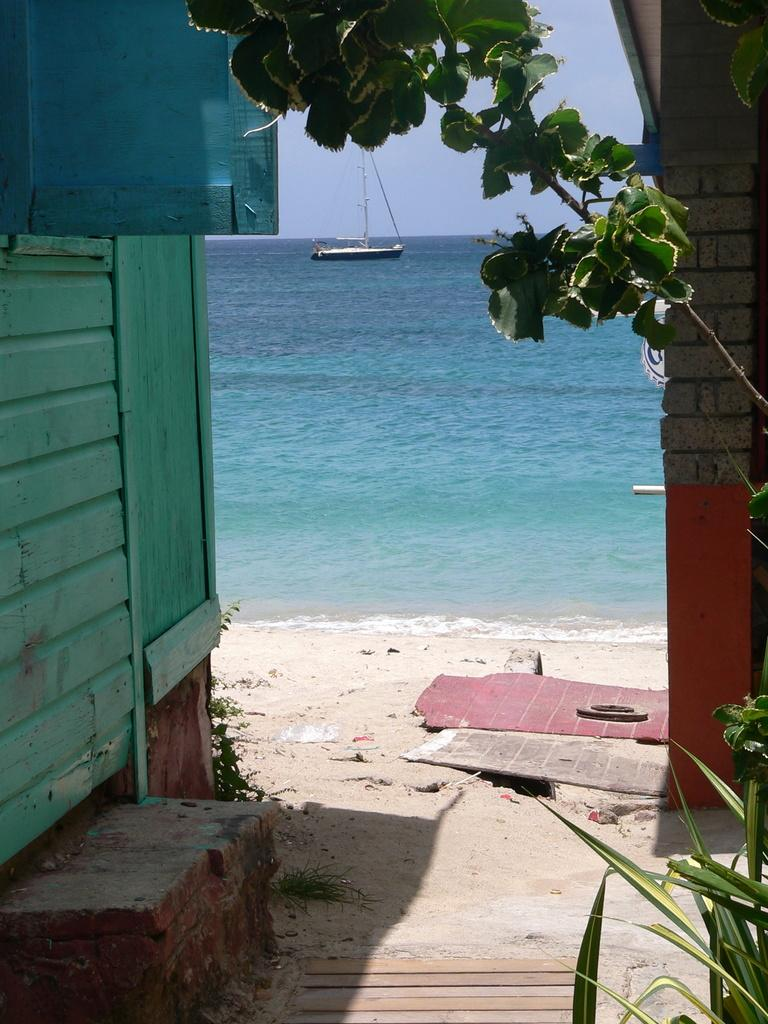What structure is located on the left side of the image? There is a house on the left side of the image. What can be seen in the background of the image? There is a boat in the background of the image, on water. What type of vegetation is on the right side of the image? There are plants on the right side of the image. What type of face can be seen on the boat in the image? There is no face present on the boat in the image; it is a boat on water. What color is the gold used to decorate the plants in the image? There is no gold used to decorate the plants in the image; the plants are not decorated with gold. 